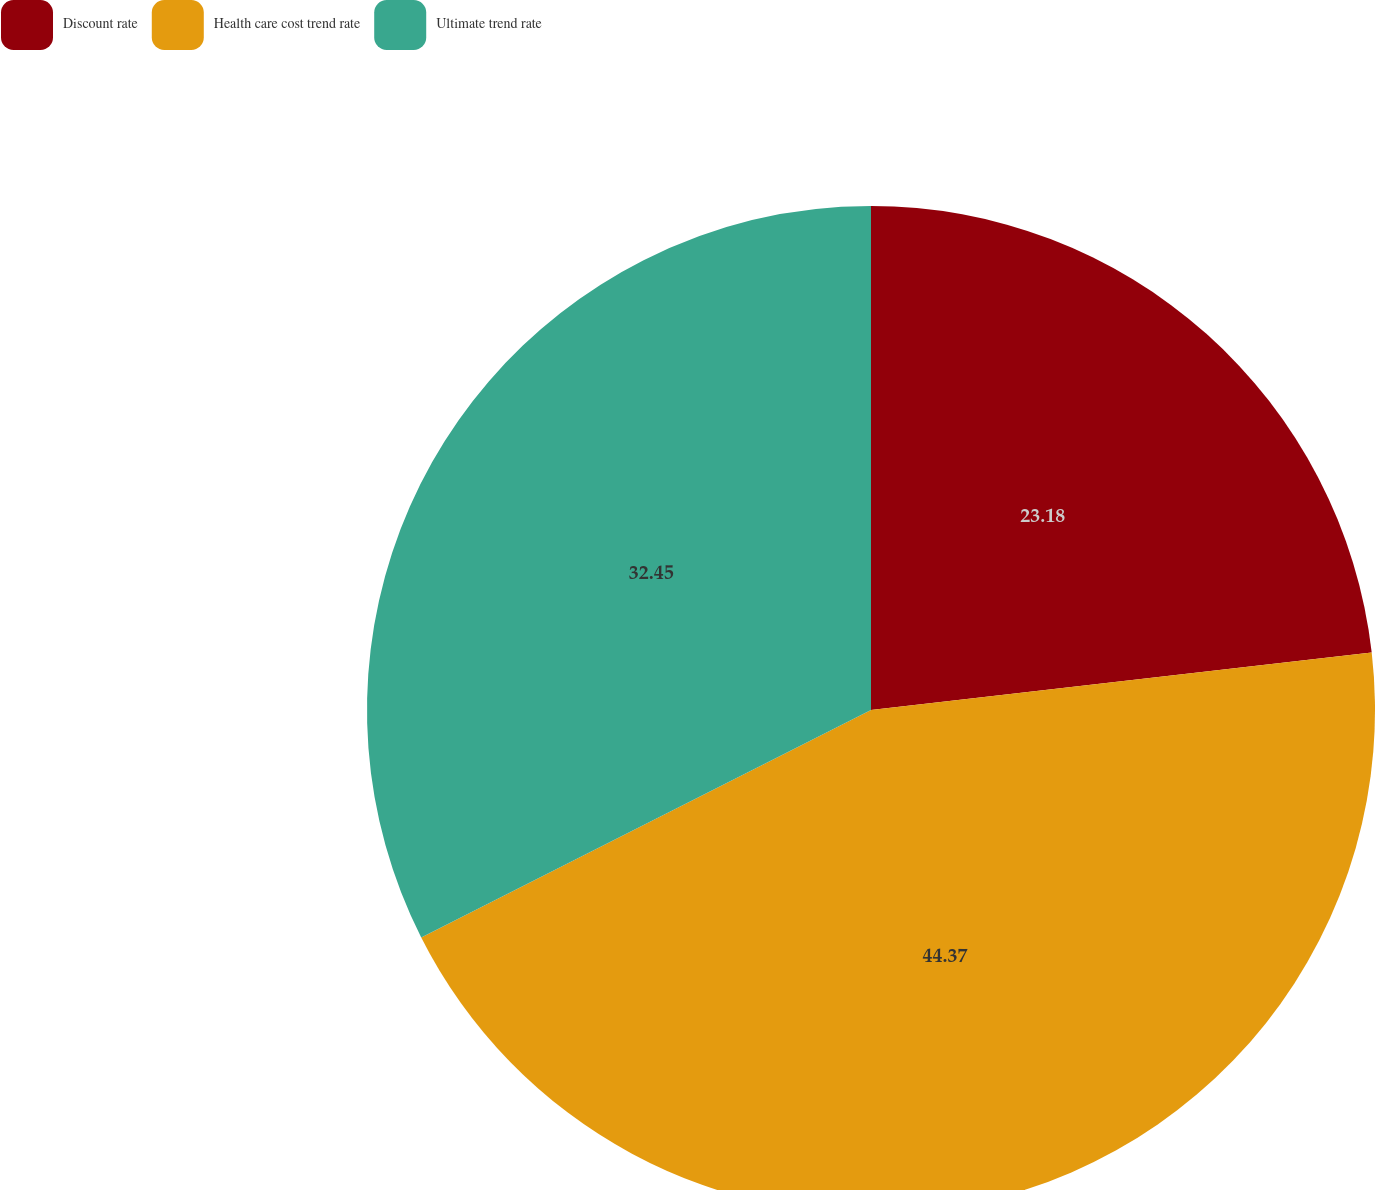Convert chart. <chart><loc_0><loc_0><loc_500><loc_500><pie_chart><fcel>Discount rate<fcel>Health care cost trend rate<fcel>Ultimate trend rate<nl><fcel>23.18%<fcel>44.37%<fcel>32.45%<nl></chart> 